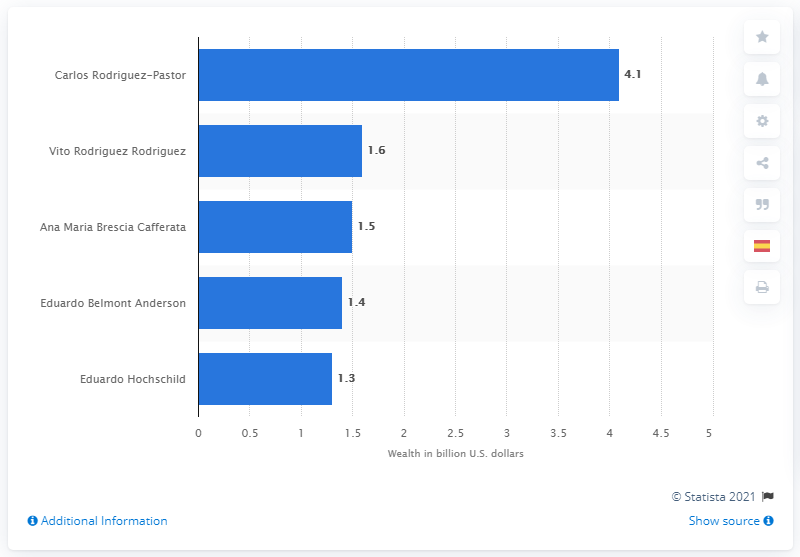List a handful of essential elements in this visual. Vito Rodriguez Rodriguez's fortune was 1.6 million. Carlos Rodriguez-Pastor was the wealthiest person in Peru in 2019. 